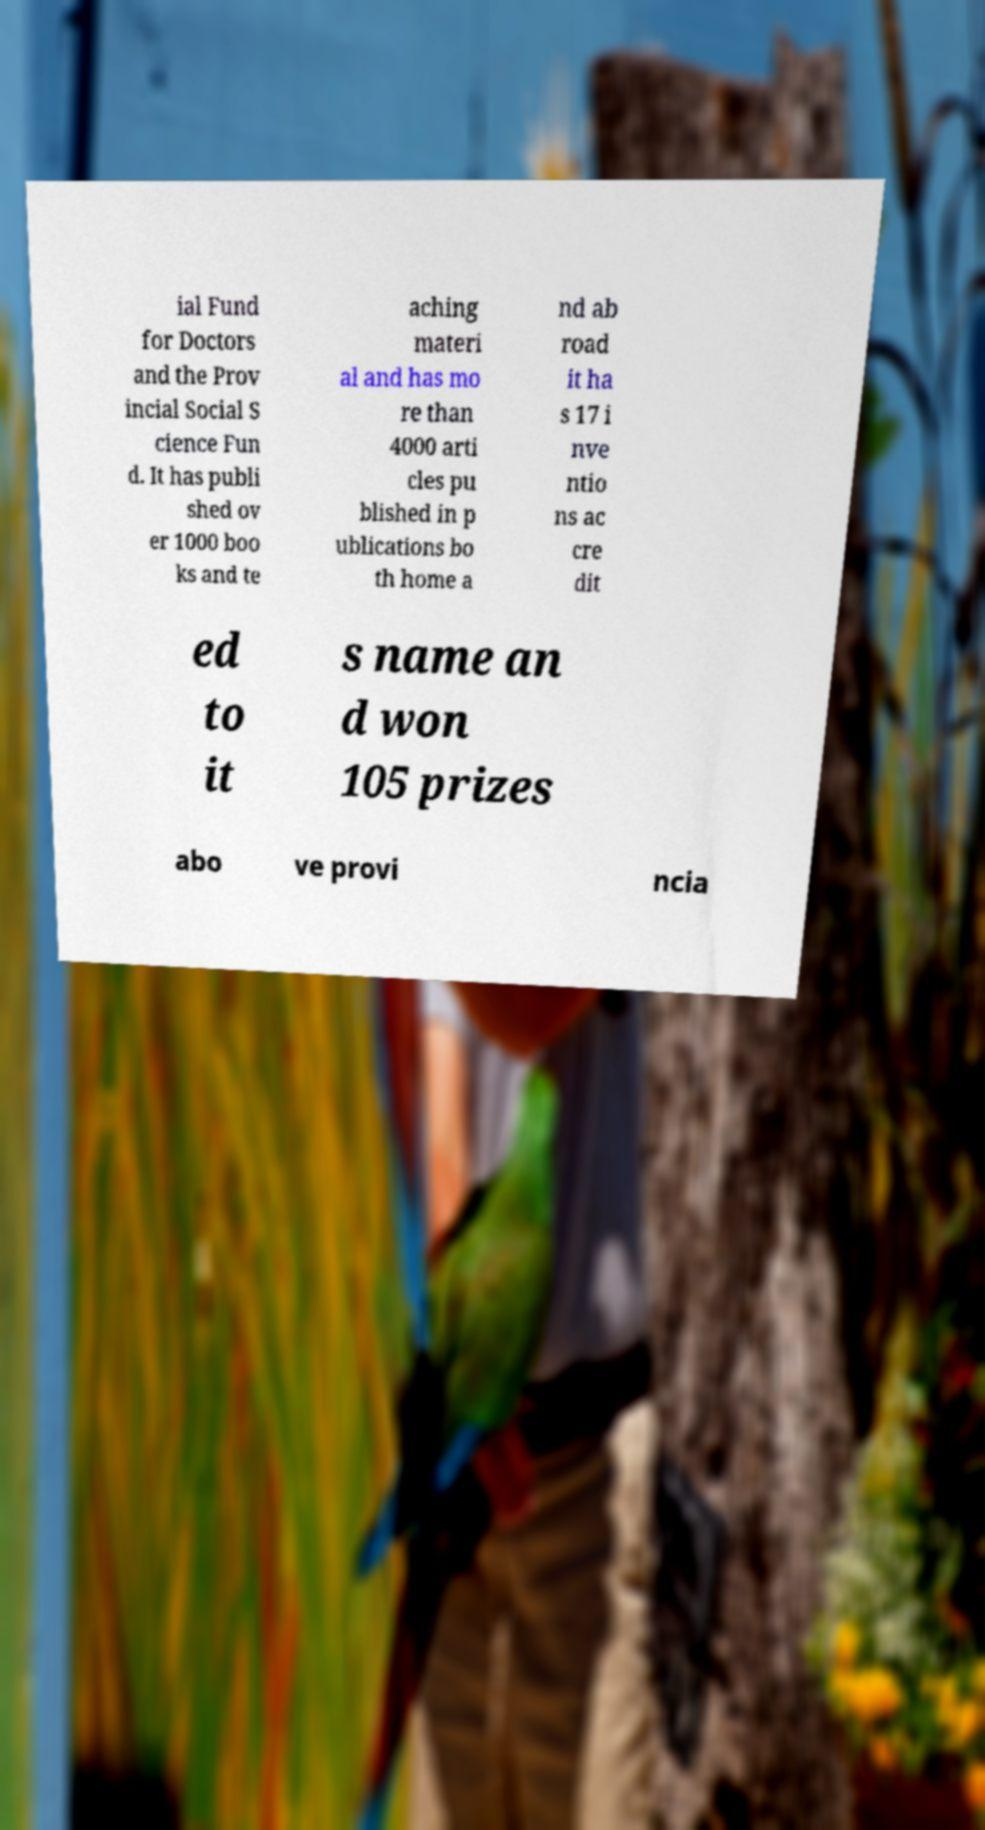What messages or text are displayed in this image? I need them in a readable, typed format. ial Fund for Doctors and the Prov incial Social S cience Fun d. It has publi shed ov er 1000 boo ks and te aching materi al and has mo re than 4000 arti cles pu blished in p ublications bo th home a nd ab road it ha s 17 i nve ntio ns ac cre dit ed to it s name an d won 105 prizes abo ve provi ncia 